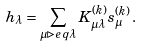Convert formula to latex. <formula><loc_0><loc_0><loc_500><loc_500>h _ { \lambda } = \sum _ { \mu \triangleright e q \lambda } K _ { \mu \lambda } ^ { ( k ) } s _ { \mu } ^ { ( k ) } \, .</formula> 